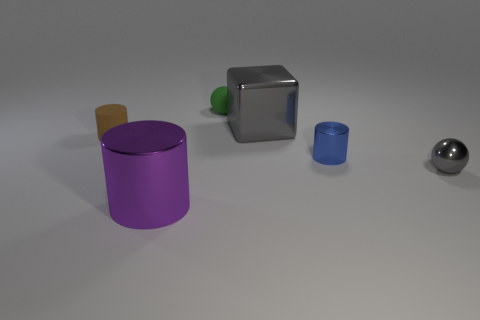What number of other things are the same size as the gray cube?
Provide a succinct answer. 1. There is a sphere that is on the left side of the metal thing that is behind the blue metallic thing; how many gray balls are to the right of it?
Offer a very short reply. 1. The big metal object to the right of the small matte ball is what color?
Make the answer very short. Gray. The thing that is both to the left of the large gray shiny cube and right of the purple shiny cylinder is made of what material?
Give a very brief answer. Rubber. How many small green matte spheres are left of the shiny cylinder that is to the left of the tiny green ball?
Provide a short and direct response. 0. What is the shape of the big purple metal object?
Give a very brief answer. Cylinder. There is a gray object that is made of the same material as the big gray block; what is its shape?
Give a very brief answer. Sphere. Do the rubber object left of the big purple metallic thing and the small green matte object have the same shape?
Your answer should be very brief. No. There is a shiny object behind the tiny matte cylinder; what is its shape?
Your answer should be compact. Cube. What shape is the tiny thing that is the same color as the large cube?
Offer a very short reply. Sphere. 